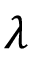<formula> <loc_0><loc_0><loc_500><loc_500>\lambda</formula> 